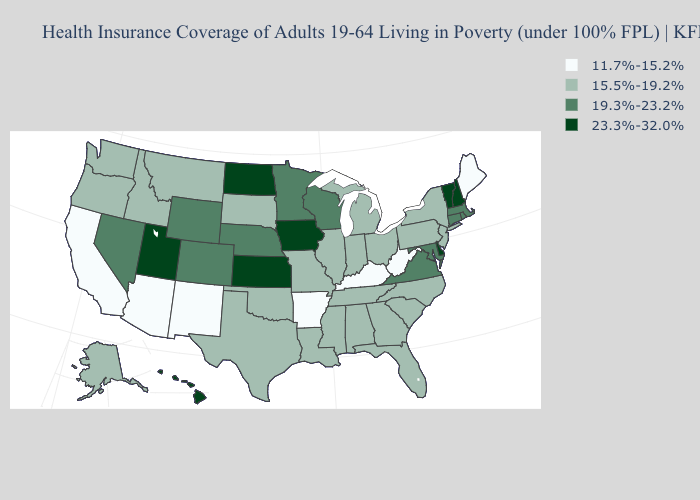How many symbols are there in the legend?
Be succinct. 4. Which states hav the highest value in the South?
Answer briefly. Delaware. Name the states that have a value in the range 23.3%-32.0%?
Answer briefly. Delaware, Hawaii, Iowa, Kansas, New Hampshire, North Dakota, Utah, Vermont. Does Georgia have a higher value than Maryland?
Be succinct. No. What is the highest value in the USA?
Answer briefly. 23.3%-32.0%. Which states hav the highest value in the West?
Short answer required. Hawaii, Utah. Name the states that have a value in the range 11.7%-15.2%?
Be succinct. Arizona, Arkansas, California, Kentucky, Maine, New Mexico, West Virginia. What is the highest value in states that border Indiana?
Keep it brief. 15.5%-19.2%. Which states have the lowest value in the USA?
Answer briefly. Arizona, Arkansas, California, Kentucky, Maine, New Mexico, West Virginia. Name the states that have a value in the range 11.7%-15.2%?
Give a very brief answer. Arizona, Arkansas, California, Kentucky, Maine, New Mexico, West Virginia. What is the value of New Mexico?
Short answer required. 11.7%-15.2%. What is the lowest value in the USA?
Give a very brief answer. 11.7%-15.2%. Name the states that have a value in the range 23.3%-32.0%?
Concise answer only. Delaware, Hawaii, Iowa, Kansas, New Hampshire, North Dakota, Utah, Vermont. Name the states that have a value in the range 15.5%-19.2%?
Write a very short answer. Alabama, Alaska, Florida, Georgia, Idaho, Illinois, Indiana, Louisiana, Michigan, Mississippi, Missouri, Montana, New Jersey, New York, North Carolina, Ohio, Oklahoma, Oregon, Pennsylvania, South Carolina, South Dakota, Tennessee, Texas, Washington. Name the states that have a value in the range 11.7%-15.2%?
Quick response, please. Arizona, Arkansas, California, Kentucky, Maine, New Mexico, West Virginia. 